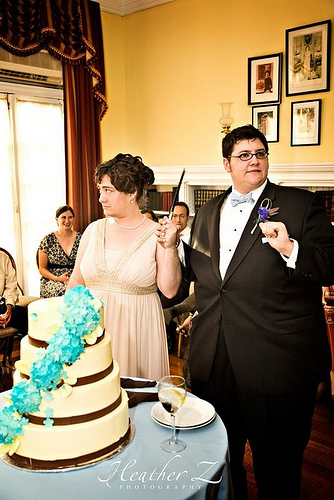Extract all visible text content from this image. Heather Z PHOTOGRAPHY 